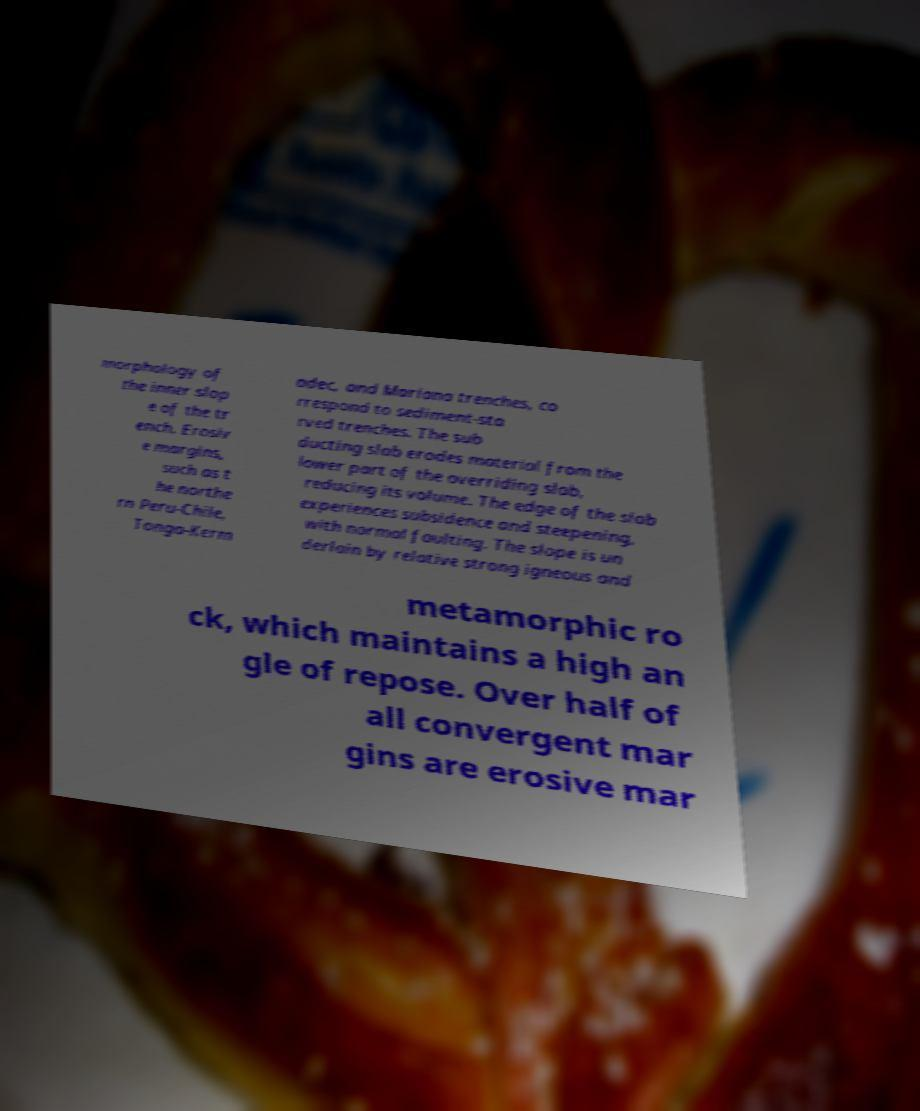Please read and relay the text visible in this image. What does it say? morphology of the inner slop e of the tr ench. Erosiv e margins, such as t he northe rn Peru-Chile, Tonga-Kerm adec, and Mariana trenches, co rrespond to sediment-sta rved trenches. The sub ducting slab erodes material from the lower part of the overriding slab, reducing its volume. The edge of the slab experiences subsidence and steepening, with normal faulting. The slope is un derlain by relative strong igneous and metamorphic ro ck, which maintains a high an gle of repose. Over half of all convergent mar gins are erosive mar 